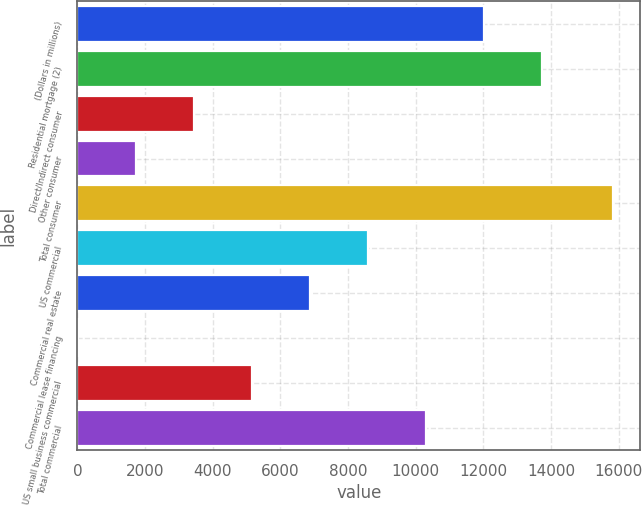<chart> <loc_0><loc_0><loc_500><loc_500><bar_chart><fcel>(Dollars in millions)<fcel>Residential mortgage (2)<fcel>Direct/Indirect consumer<fcel>Other consumer<fcel>Total consumer<fcel>US commercial<fcel>Commercial real estate<fcel>Commercial lease financing<fcel>US small business commercial<fcel>Total commercial<nl><fcel>12009.1<fcel>13722.4<fcel>3442.6<fcel>1729.3<fcel>15840<fcel>8582.5<fcel>6869.2<fcel>16<fcel>5155.9<fcel>10295.8<nl></chart> 